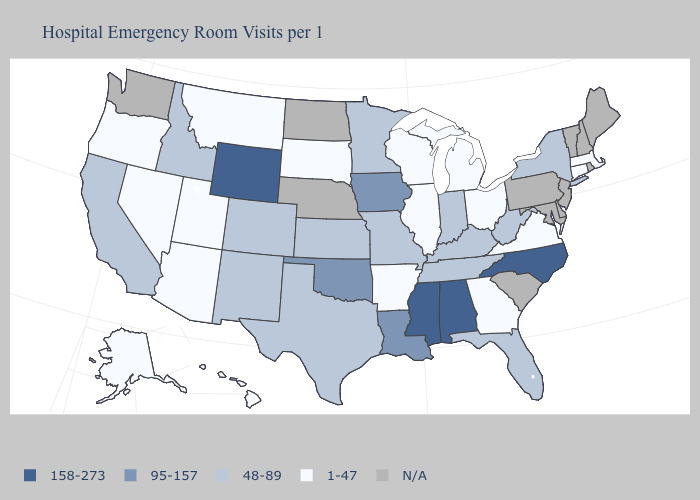What is the value of Rhode Island?
Quick response, please. N/A. Among the states that border Utah , which have the highest value?
Concise answer only. Wyoming. Name the states that have a value in the range 158-273?
Keep it brief. Alabama, Mississippi, North Carolina, Wyoming. What is the value of North Dakota?
Write a very short answer. N/A. How many symbols are there in the legend?
Give a very brief answer. 5. What is the highest value in states that border Colorado?
Concise answer only. 158-273. What is the value of Maine?
Write a very short answer. N/A. What is the lowest value in the USA?
Give a very brief answer. 1-47. Which states have the highest value in the USA?
Quick response, please. Alabama, Mississippi, North Carolina, Wyoming. What is the lowest value in the USA?
Give a very brief answer. 1-47. Does Alabama have the highest value in the USA?
Give a very brief answer. Yes. What is the lowest value in the Northeast?
Keep it brief. 1-47. Which states have the lowest value in the USA?
Concise answer only. Alaska, Arizona, Arkansas, Connecticut, Georgia, Hawaii, Illinois, Massachusetts, Michigan, Montana, Nevada, Ohio, Oregon, South Dakota, Utah, Virginia, Wisconsin. Among the states that border Nebraska , which have the lowest value?
Concise answer only. South Dakota. What is the lowest value in states that border Colorado?
Concise answer only. 1-47. 